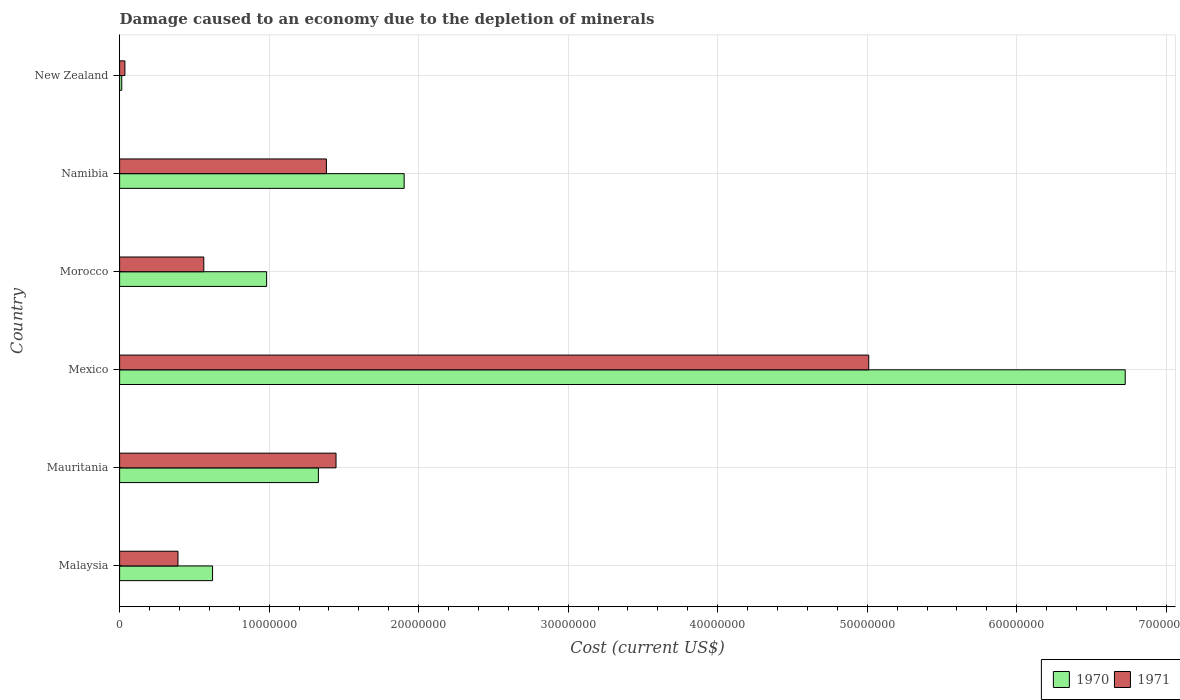How many different coloured bars are there?
Provide a short and direct response. 2. How many groups of bars are there?
Offer a very short reply. 6. Are the number of bars on each tick of the Y-axis equal?
Provide a succinct answer. Yes. How many bars are there on the 5th tick from the bottom?
Keep it short and to the point. 2. What is the cost of damage caused due to the depletion of minerals in 1970 in Namibia?
Ensure brevity in your answer.  1.90e+07. Across all countries, what is the maximum cost of damage caused due to the depletion of minerals in 1971?
Offer a very short reply. 5.01e+07. Across all countries, what is the minimum cost of damage caused due to the depletion of minerals in 1970?
Your answer should be very brief. 1.43e+05. In which country was the cost of damage caused due to the depletion of minerals in 1970 maximum?
Provide a succinct answer. Mexico. In which country was the cost of damage caused due to the depletion of minerals in 1970 minimum?
Your answer should be very brief. New Zealand. What is the total cost of damage caused due to the depletion of minerals in 1970 in the graph?
Give a very brief answer. 1.16e+08. What is the difference between the cost of damage caused due to the depletion of minerals in 1970 in Mexico and that in Morocco?
Your answer should be very brief. 5.74e+07. What is the difference between the cost of damage caused due to the depletion of minerals in 1971 in Morocco and the cost of damage caused due to the depletion of minerals in 1970 in Malaysia?
Ensure brevity in your answer.  -5.86e+05. What is the average cost of damage caused due to the depletion of minerals in 1970 per country?
Provide a short and direct response. 1.93e+07. What is the difference between the cost of damage caused due to the depletion of minerals in 1970 and cost of damage caused due to the depletion of minerals in 1971 in New Zealand?
Make the answer very short. -2.11e+05. What is the ratio of the cost of damage caused due to the depletion of minerals in 1970 in Morocco to that in New Zealand?
Provide a short and direct response. 68.59. What is the difference between the highest and the second highest cost of damage caused due to the depletion of minerals in 1971?
Make the answer very short. 3.56e+07. What is the difference between the highest and the lowest cost of damage caused due to the depletion of minerals in 1970?
Give a very brief answer. 6.71e+07. In how many countries, is the cost of damage caused due to the depletion of minerals in 1971 greater than the average cost of damage caused due to the depletion of minerals in 1971 taken over all countries?
Your response must be concise. 1. Is the sum of the cost of damage caused due to the depletion of minerals in 1970 in Mauritania and Morocco greater than the maximum cost of damage caused due to the depletion of minerals in 1971 across all countries?
Offer a terse response. No. Are all the bars in the graph horizontal?
Ensure brevity in your answer.  Yes. Does the graph contain any zero values?
Keep it short and to the point. No. How are the legend labels stacked?
Offer a very short reply. Horizontal. What is the title of the graph?
Your answer should be compact. Damage caused to an economy due to the depletion of minerals. What is the label or title of the X-axis?
Your answer should be compact. Cost (current US$). What is the label or title of the Y-axis?
Offer a very short reply. Country. What is the Cost (current US$) in 1970 in Malaysia?
Ensure brevity in your answer.  6.22e+06. What is the Cost (current US$) of 1971 in Malaysia?
Give a very brief answer. 3.90e+06. What is the Cost (current US$) in 1970 in Mauritania?
Give a very brief answer. 1.33e+07. What is the Cost (current US$) in 1971 in Mauritania?
Provide a succinct answer. 1.45e+07. What is the Cost (current US$) of 1970 in Mexico?
Your response must be concise. 6.73e+07. What is the Cost (current US$) in 1971 in Mexico?
Provide a succinct answer. 5.01e+07. What is the Cost (current US$) of 1970 in Morocco?
Provide a succinct answer. 9.83e+06. What is the Cost (current US$) in 1971 in Morocco?
Ensure brevity in your answer.  5.63e+06. What is the Cost (current US$) in 1970 in Namibia?
Provide a succinct answer. 1.90e+07. What is the Cost (current US$) in 1971 in Namibia?
Offer a very short reply. 1.38e+07. What is the Cost (current US$) of 1970 in New Zealand?
Keep it short and to the point. 1.43e+05. What is the Cost (current US$) in 1971 in New Zealand?
Make the answer very short. 3.55e+05. Across all countries, what is the maximum Cost (current US$) of 1970?
Keep it short and to the point. 6.73e+07. Across all countries, what is the maximum Cost (current US$) in 1971?
Give a very brief answer. 5.01e+07. Across all countries, what is the minimum Cost (current US$) in 1970?
Your answer should be compact. 1.43e+05. Across all countries, what is the minimum Cost (current US$) of 1971?
Your answer should be very brief. 3.55e+05. What is the total Cost (current US$) in 1970 in the graph?
Make the answer very short. 1.16e+08. What is the total Cost (current US$) of 1971 in the graph?
Your answer should be compact. 8.83e+07. What is the difference between the Cost (current US$) of 1970 in Malaysia and that in Mauritania?
Ensure brevity in your answer.  -7.08e+06. What is the difference between the Cost (current US$) of 1971 in Malaysia and that in Mauritania?
Your answer should be very brief. -1.06e+07. What is the difference between the Cost (current US$) of 1970 in Malaysia and that in Mexico?
Provide a short and direct response. -6.10e+07. What is the difference between the Cost (current US$) in 1971 in Malaysia and that in Mexico?
Provide a succinct answer. -4.62e+07. What is the difference between the Cost (current US$) in 1970 in Malaysia and that in Morocco?
Keep it short and to the point. -3.61e+06. What is the difference between the Cost (current US$) in 1971 in Malaysia and that in Morocco?
Your response must be concise. -1.73e+06. What is the difference between the Cost (current US$) of 1970 in Malaysia and that in Namibia?
Keep it short and to the point. -1.28e+07. What is the difference between the Cost (current US$) of 1971 in Malaysia and that in Namibia?
Ensure brevity in your answer.  -9.93e+06. What is the difference between the Cost (current US$) in 1970 in Malaysia and that in New Zealand?
Give a very brief answer. 6.07e+06. What is the difference between the Cost (current US$) in 1971 in Malaysia and that in New Zealand?
Make the answer very short. 3.55e+06. What is the difference between the Cost (current US$) of 1970 in Mauritania and that in Mexico?
Offer a terse response. -5.40e+07. What is the difference between the Cost (current US$) of 1971 in Mauritania and that in Mexico?
Offer a terse response. -3.56e+07. What is the difference between the Cost (current US$) of 1970 in Mauritania and that in Morocco?
Give a very brief answer. 3.46e+06. What is the difference between the Cost (current US$) of 1971 in Mauritania and that in Morocco?
Provide a short and direct response. 8.84e+06. What is the difference between the Cost (current US$) of 1970 in Mauritania and that in Namibia?
Provide a succinct answer. -5.74e+06. What is the difference between the Cost (current US$) in 1971 in Mauritania and that in Namibia?
Your response must be concise. 6.44e+05. What is the difference between the Cost (current US$) in 1970 in Mauritania and that in New Zealand?
Make the answer very short. 1.32e+07. What is the difference between the Cost (current US$) of 1971 in Mauritania and that in New Zealand?
Your answer should be very brief. 1.41e+07. What is the difference between the Cost (current US$) of 1970 in Mexico and that in Morocco?
Provide a short and direct response. 5.74e+07. What is the difference between the Cost (current US$) in 1971 in Mexico and that in Morocco?
Offer a terse response. 4.45e+07. What is the difference between the Cost (current US$) in 1970 in Mexico and that in Namibia?
Provide a succinct answer. 4.82e+07. What is the difference between the Cost (current US$) of 1971 in Mexico and that in Namibia?
Provide a short and direct response. 3.63e+07. What is the difference between the Cost (current US$) in 1970 in Mexico and that in New Zealand?
Give a very brief answer. 6.71e+07. What is the difference between the Cost (current US$) in 1971 in Mexico and that in New Zealand?
Your response must be concise. 4.97e+07. What is the difference between the Cost (current US$) in 1970 in Morocco and that in Namibia?
Your answer should be very brief. -9.20e+06. What is the difference between the Cost (current US$) in 1971 in Morocco and that in Namibia?
Make the answer very short. -8.20e+06. What is the difference between the Cost (current US$) in 1970 in Morocco and that in New Zealand?
Offer a terse response. 9.69e+06. What is the difference between the Cost (current US$) of 1971 in Morocco and that in New Zealand?
Provide a succinct answer. 5.28e+06. What is the difference between the Cost (current US$) of 1970 in Namibia and that in New Zealand?
Your answer should be compact. 1.89e+07. What is the difference between the Cost (current US$) of 1971 in Namibia and that in New Zealand?
Your answer should be very brief. 1.35e+07. What is the difference between the Cost (current US$) in 1970 in Malaysia and the Cost (current US$) in 1971 in Mauritania?
Make the answer very short. -8.26e+06. What is the difference between the Cost (current US$) of 1970 in Malaysia and the Cost (current US$) of 1971 in Mexico?
Your answer should be very brief. -4.39e+07. What is the difference between the Cost (current US$) of 1970 in Malaysia and the Cost (current US$) of 1971 in Morocco?
Your answer should be very brief. 5.86e+05. What is the difference between the Cost (current US$) in 1970 in Malaysia and the Cost (current US$) in 1971 in Namibia?
Offer a terse response. -7.61e+06. What is the difference between the Cost (current US$) of 1970 in Malaysia and the Cost (current US$) of 1971 in New Zealand?
Your answer should be compact. 5.86e+06. What is the difference between the Cost (current US$) in 1970 in Mauritania and the Cost (current US$) in 1971 in Mexico?
Offer a very short reply. -3.68e+07. What is the difference between the Cost (current US$) of 1970 in Mauritania and the Cost (current US$) of 1971 in Morocco?
Offer a very short reply. 7.66e+06. What is the difference between the Cost (current US$) of 1970 in Mauritania and the Cost (current US$) of 1971 in Namibia?
Offer a terse response. -5.35e+05. What is the difference between the Cost (current US$) of 1970 in Mauritania and the Cost (current US$) of 1971 in New Zealand?
Offer a very short reply. 1.29e+07. What is the difference between the Cost (current US$) of 1970 in Mexico and the Cost (current US$) of 1971 in Morocco?
Your response must be concise. 6.16e+07. What is the difference between the Cost (current US$) of 1970 in Mexico and the Cost (current US$) of 1971 in Namibia?
Give a very brief answer. 5.34e+07. What is the difference between the Cost (current US$) of 1970 in Mexico and the Cost (current US$) of 1971 in New Zealand?
Give a very brief answer. 6.69e+07. What is the difference between the Cost (current US$) in 1970 in Morocco and the Cost (current US$) in 1971 in Namibia?
Your answer should be very brief. -4.00e+06. What is the difference between the Cost (current US$) in 1970 in Morocco and the Cost (current US$) in 1971 in New Zealand?
Offer a very short reply. 9.48e+06. What is the difference between the Cost (current US$) of 1970 in Namibia and the Cost (current US$) of 1971 in New Zealand?
Offer a very short reply. 1.87e+07. What is the average Cost (current US$) in 1970 per country?
Offer a terse response. 1.93e+07. What is the average Cost (current US$) of 1971 per country?
Provide a short and direct response. 1.47e+07. What is the difference between the Cost (current US$) of 1970 and Cost (current US$) of 1971 in Malaysia?
Your answer should be compact. 2.31e+06. What is the difference between the Cost (current US$) in 1970 and Cost (current US$) in 1971 in Mauritania?
Your response must be concise. -1.18e+06. What is the difference between the Cost (current US$) of 1970 and Cost (current US$) of 1971 in Mexico?
Keep it short and to the point. 1.72e+07. What is the difference between the Cost (current US$) in 1970 and Cost (current US$) in 1971 in Morocco?
Make the answer very short. 4.20e+06. What is the difference between the Cost (current US$) in 1970 and Cost (current US$) in 1971 in Namibia?
Your answer should be very brief. 5.20e+06. What is the difference between the Cost (current US$) in 1970 and Cost (current US$) in 1971 in New Zealand?
Your response must be concise. -2.11e+05. What is the ratio of the Cost (current US$) in 1970 in Malaysia to that in Mauritania?
Make the answer very short. 0.47. What is the ratio of the Cost (current US$) in 1971 in Malaysia to that in Mauritania?
Your answer should be very brief. 0.27. What is the ratio of the Cost (current US$) of 1970 in Malaysia to that in Mexico?
Your response must be concise. 0.09. What is the ratio of the Cost (current US$) in 1971 in Malaysia to that in Mexico?
Keep it short and to the point. 0.08. What is the ratio of the Cost (current US$) in 1970 in Malaysia to that in Morocco?
Provide a succinct answer. 0.63. What is the ratio of the Cost (current US$) in 1971 in Malaysia to that in Morocco?
Provide a short and direct response. 0.69. What is the ratio of the Cost (current US$) in 1970 in Malaysia to that in Namibia?
Ensure brevity in your answer.  0.33. What is the ratio of the Cost (current US$) of 1971 in Malaysia to that in Namibia?
Provide a succinct answer. 0.28. What is the ratio of the Cost (current US$) in 1970 in Malaysia to that in New Zealand?
Make the answer very short. 43.37. What is the ratio of the Cost (current US$) in 1971 in Malaysia to that in New Zealand?
Make the answer very short. 11. What is the ratio of the Cost (current US$) of 1970 in Mauritania to that in Mexico?
Give a very brief answer. 0.2. What is the ratio of the Cost (current US$) in 1971 in Mauritania to that in Mexico?
Your answer should be very brief. 0.29. What is the ratio of the Cost (current US$) in 1970 in Mauritania to that in Morocco?
Provide a succinct answer. 1.35. What is the ratio of the Cost (current US$) of 1971 in Mauritania to that in Morocco?
Your response must be concise. 2.57. What is the ratio of the Cost (current US$) of 1970 in Mauritania to that in Namibia?
Give a very brief answer. 0.7. What is the ratio of the Cost (current US$) of 1971 in Mauritania to that in Namibia?
Offer a terse response. 1.05. What is the ratio of the Cost (current US$) of 1970 in Mauritania to that in New Zealand?
Give a very brief answer. 92.74. What is the ratio of the Cost (current US$) in 1971 in Mauritania to that in New Zealand?
Provide a short and direct response. 40.79. What is the ratio of the Cost (current US$) of 1970 in Mexico to that in Morocco?
Offer a terse response. 6.84. What is the ratio of the Cost (current US$) in 1971 in Mexico to that in Morocco?
Provide a short and direct response. 8.9. What is the ratio of the Cost (current US$) of 1970 in Mexico to that in Namibia?
Provide a short and direct response. 3.53. What is the ratio of the Cost (current US$) of 1971 in Mexico to that in Namibia?
Provide a short and direct response. 3.62. What is the ratio of the Cost (current US$) of 1970 in Mexico to that in New Zealand?
Offer a terse response. 469.14. What is the ratio of the Cost (current US$) in 1971 in Mexico to that in New Zealand?
Ensure brevity in your answer.  141.19. What is the ratio of the Cost (current US$) in 1970 in Morocco to that in Namibia?
Ensure brevity in your answer.  0.52. What is the ratio of the Cost (current US$) of 1971 in Morocco to that in Namibia?
Offer a terse response. 0.41. What is the ratio of the Cost (current US$) in 1970 in Morocco to that in New Zealand?
Give a very brief answer. 68.59. What is the ratio of the Cost (current US$) in 1971 in Morocco to that in New Zealand?
Your answer should be compact. 15.87. What is the ratio of the Cost (current US$) in 1970 in Namibia to that in New Zealand?
Make the answer very short. 132.75. What is the ratio of the Cost (current US$) of 1971 in Namibia to that in New Zealand?
Provide a succinct answer. 38.97. What is the difference between the highest and the second highest Cost (current US$) of 1970?
Keep it short and to the point. 4.82e+07. What is the difference between the highest and the second highest Cost (current US$) of 1971?
Offer a terse response. 3.56e+07. What is the difference between the highest and the lowest Cost (current US$) in 1970?
Your response must be concise. 6.71e+07. What is the difference between the highest and the lowest Cost (current US$) in 1971?
Your response must be concise. 4.97e+07. 